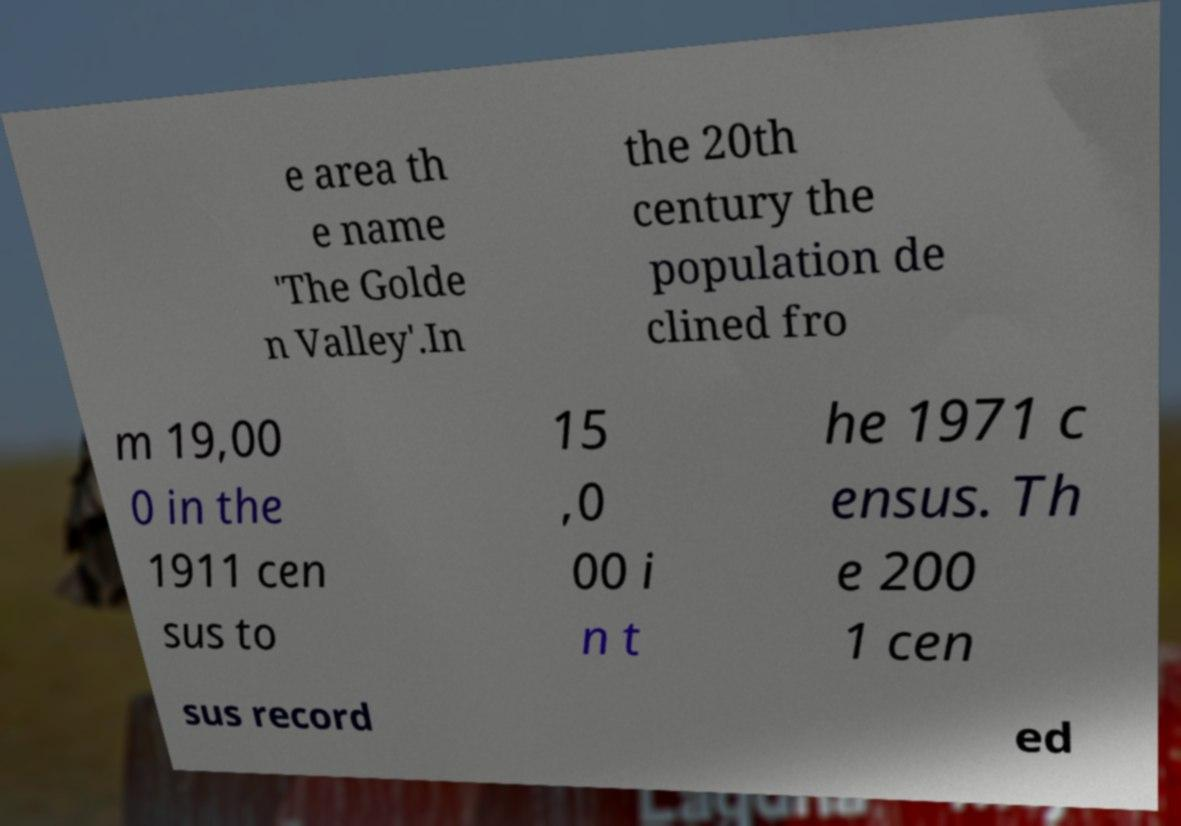I need the written content from this picture converted into text. Can you do that? e area th e name 'The Golde n Valley'.In the 20th century the population de clined fro m 19,00 0 in the 1911 cen sus to 15 ,0 00 i n t he 1971 c ensus. Th e 200 1 cen sus record ed 